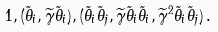<formula> <loc_0><loc_0><loc_500><loc_500>1 , ( \tilde { \theta } _ { i } , \widetilde { \gamma } \tilde { \theta } _ { i } ) , ( \tilde { \theta } _ { i } \tilde { \theta } _ { j } , \widetilde { \gamma } \tilde { \theta } _ { i } \tilde { \theta } _ { i } , \widetilde { \gamma } ^ { 2 } \tilde { \theta } _ { i } \tilde { \theta } _ { j } ) \, .</formula> 